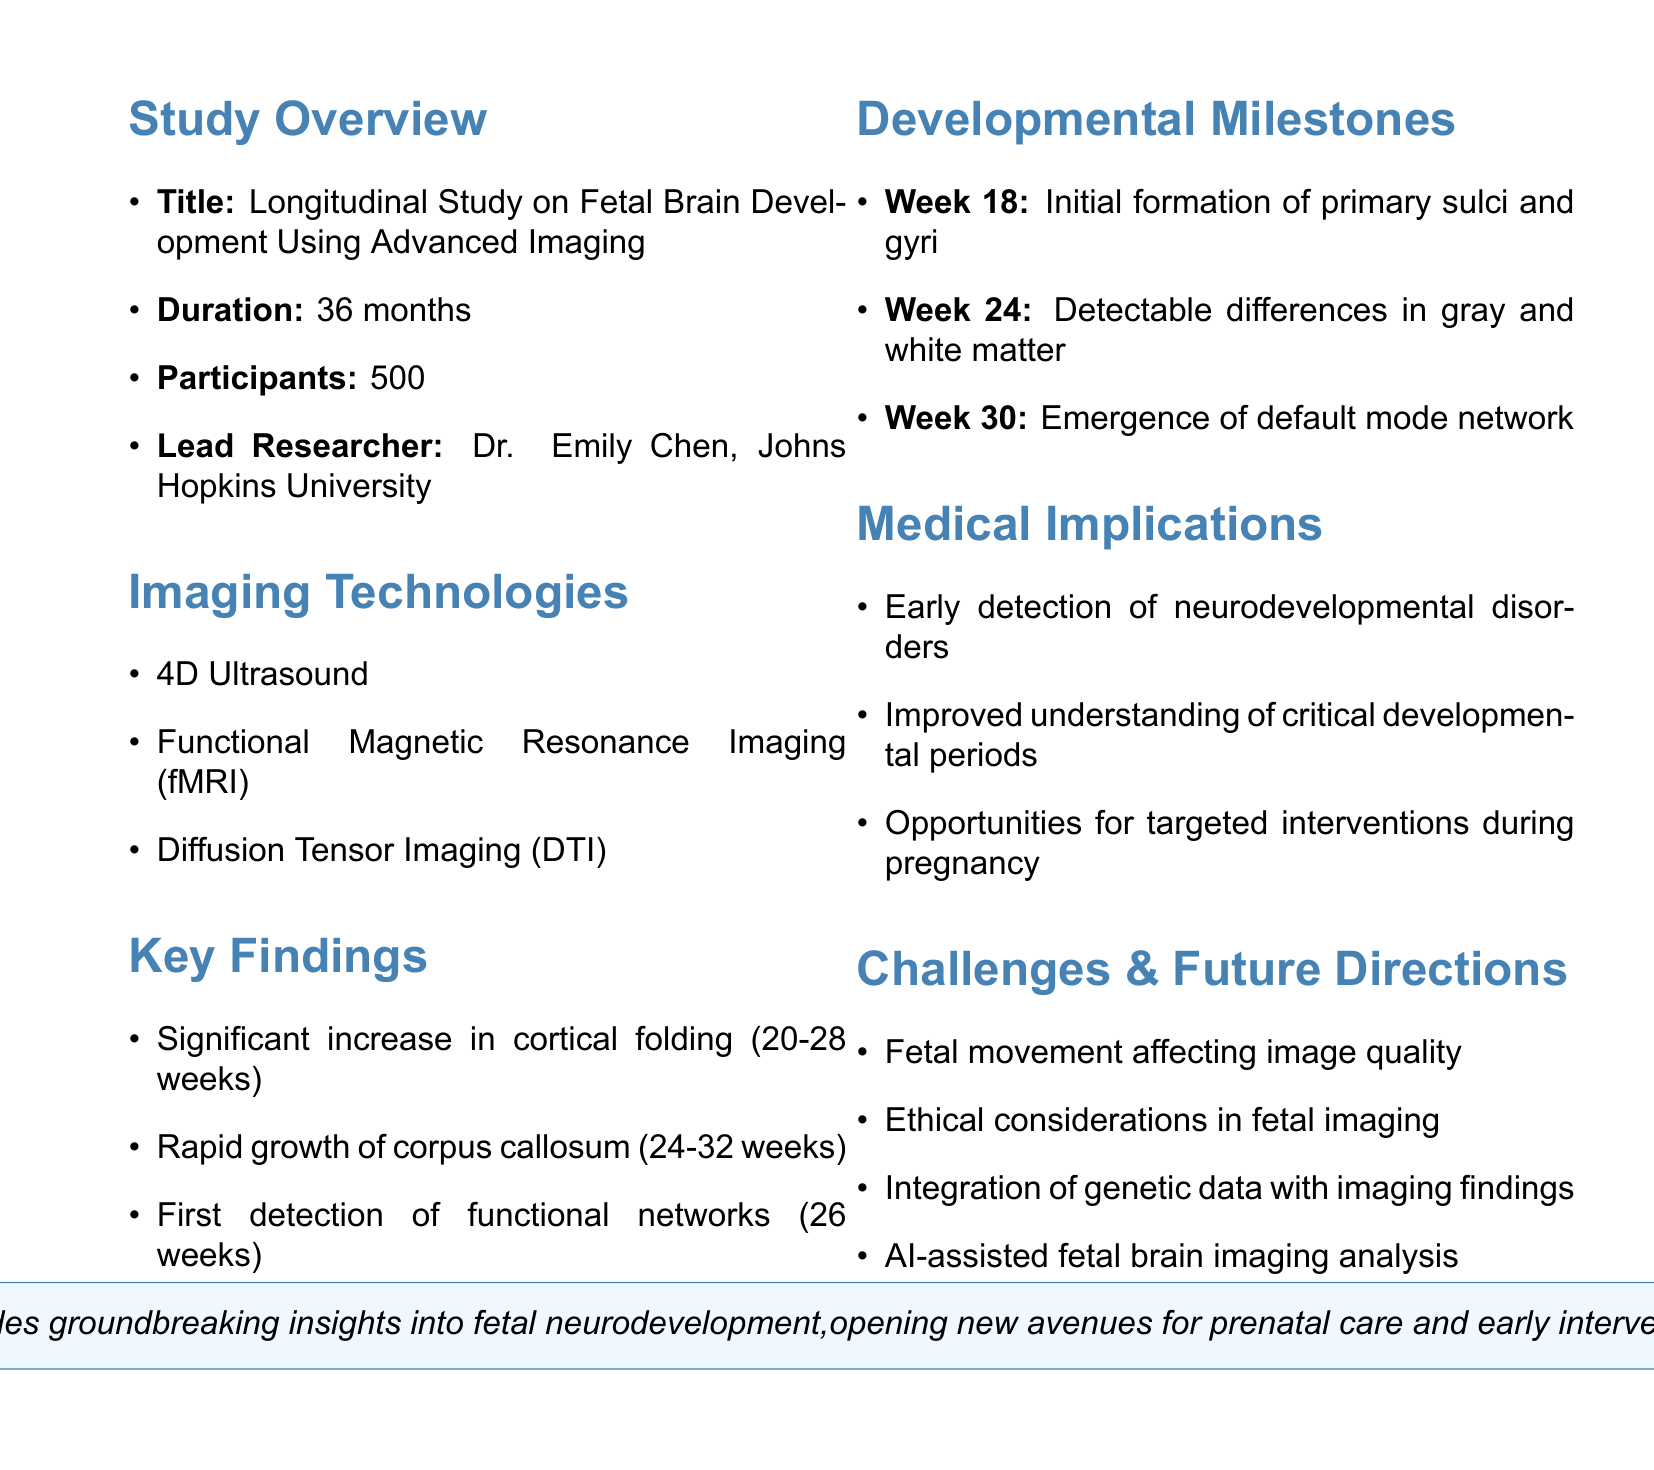What is the title of the study? The title is provided in the overview section of the document.
Answer: Longitudinal Study on Fetal Brain Development Using Advanced Imaging Who is the lead researcher? The document specifies the name and affiliation of the lead researcher.
Answer: Dr. Emily Chen, Johns Hopkins University How many participants were involved in the study? The total number of participants is listed in the study overview.
Answer: 500 What imaging technology detects functional networks at 26 weeks? This information is derived from the key findings section about specific advancements in imaging.
Answer: Functional Magnetic Resonance Imaging (fMRI) What was observed at week 24 of the study? This is documented under the developmental milestones, indicating specific brain development changes.
Answer: Detectable differences in gray and white matter What significant growth was noted between 24-32 weeks? The key findings summarize rapid growth in a specific brain structure during this period.
Answer: Corpus callosum What ethical consideration is mentioned in the challenges and limitations? The document highlights limitations regarding the ethical aspects of fetal imaging studies.
Answer: Ethical considerations in fetal imaging studies What is a future research direction mentioned? Specific future research directions are highlighted at the end of the document, indicating areas for further exploration.
Answer: Integration of genetic data with imaging findings 